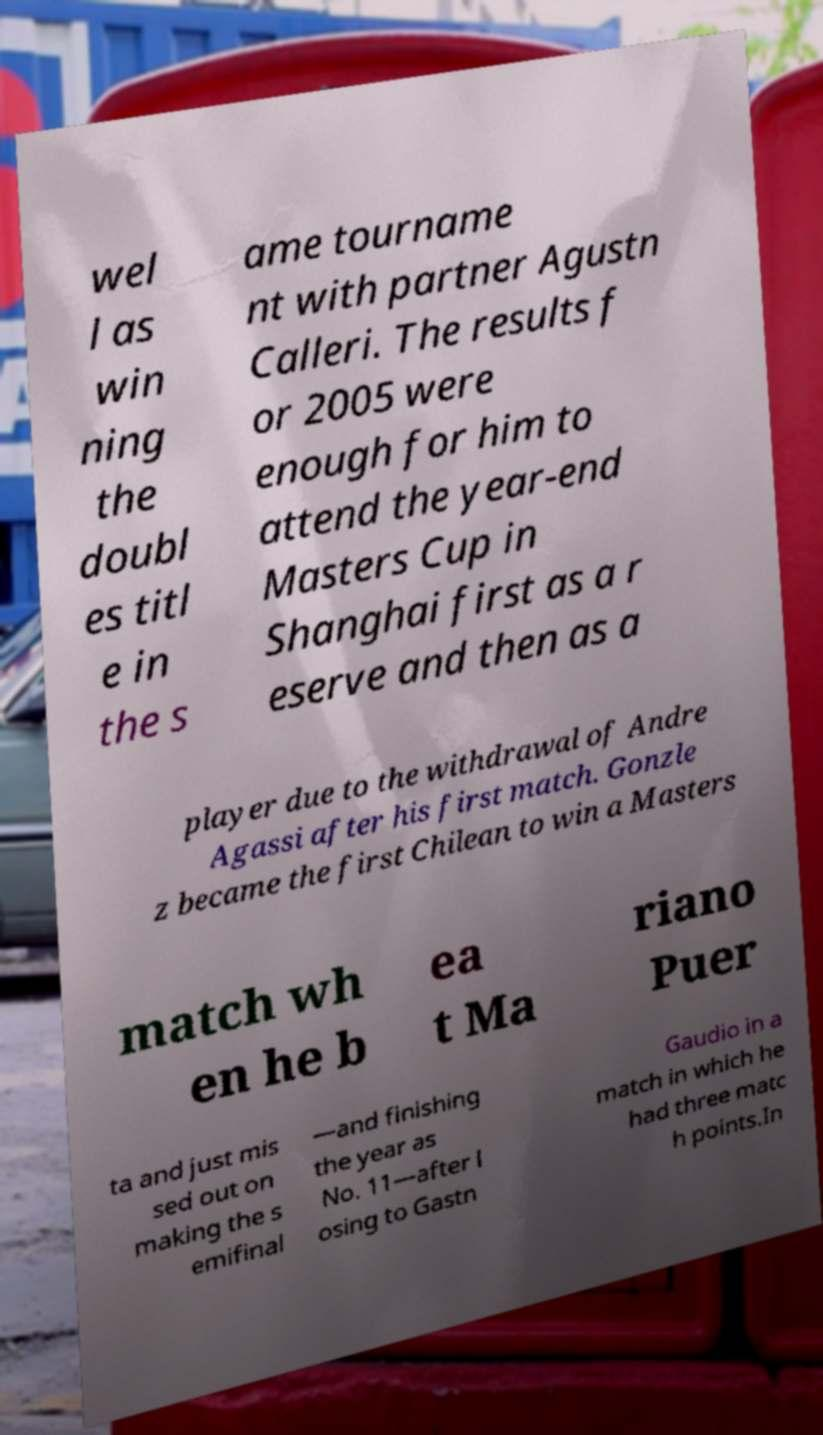Could you assist in decoding the text presented in this image and type it out clearly? wel l as win ning the doubl es titl e in the s ame tourname nt with partner Agustn Calleri. The results f or 2005 were enough for him to attend the year-end Masters Cup in Shanghai first as a r eserve and then as a player due to the withdrawal of Andre Agassi after his first match. Gonzle z became the first Chilean to win a Masters match wh en he b ea t Ma riano Puer ta and just mis sed out on making the s emifinal —and finishing the year as No. 11—after l osing to Gastn Gaudio in a match in which he had three matc h points.In 